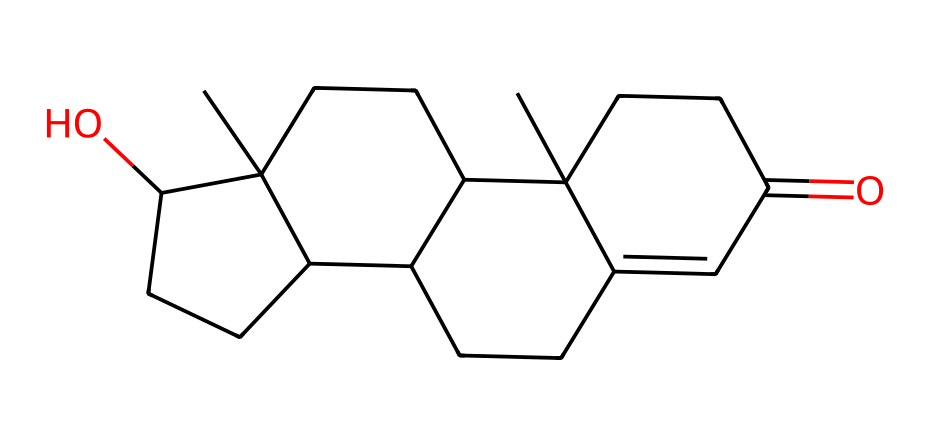What is the molecular formula of testosterone? To determine the molecular formula, we need to count the carbon (C), hydrogen (H), and oxygen (O) atoms in the structure. By analyzing the SMILES representation, we find there are 19 carbon atoms, 28 hydrogen atoms, and 2 oxygen atoms. Thus, the molecular formula is C19H28O2.
Answer: C19H28O2 How many rings are present in the testosterone molecule? Analyzing the structure results from the SMILES, the molecule can be observed to contain four distinct rings. These are indicated by the numbers in the SMILES that denote ring connections (like 1, 2, 3, and 4).
Answer: 4 What type of hormone is testosterone classified as? Testosterone is classified as a steroid hormone, which is indicated by its multi-ring carbon structure typical of steroids. This structural feature is seen in the arrangement of its atoms in the SMILES notation.
Answer: steroid How many hydroxyl (OH) groups are present? By examining the SMILES representation, we can identify only one hydroxyl (OH) group in the molecule, indicated by the presence of an 'O' that is connected to a carbon chain.
Answer: 1 What is the primary functional group in testosterone? The primary functional group in testosterone is the ketone group, due to the presence of a carbonyl (C=O) within the structure. This is indicated specifically by the structure surrounding the carbon and oxygen in the rings.
Answer: ketone 